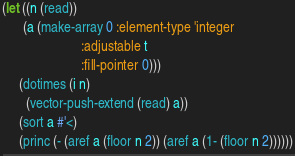Convert code to text. <code><loc_0><loc_0><loc_500><loc_500><_Lisp_>(let ((n (read))
      (a (make-array 0 :element-type 'integer
                       :adjustable t
                       :fill-pointer 0)))
     (dotimes (i n)
       (vector-push-extend (read) a))
     (sort a #'<)
     (princ (- (aref a (floor n 2)) (aref a (1- (floor n 2))))))</code> 